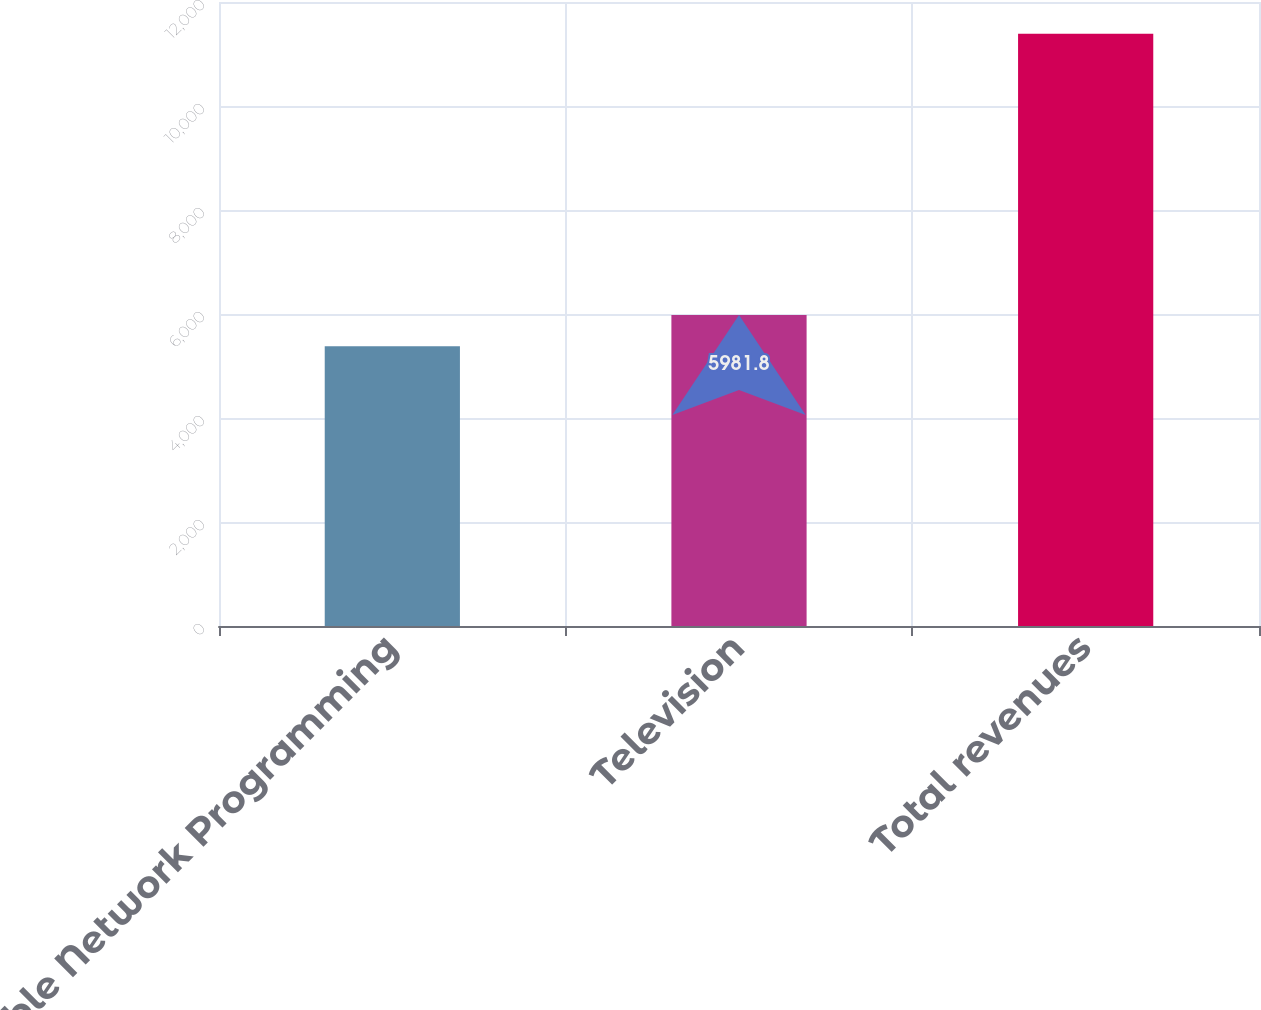Convert chart. <chart><loc_0><loc_0><loc_500><loc_500><bar_chart><fcel>Cable Network Programming<fcel>Television<fcel>Total revenues<nl><fcel>5381<fcel>5981.8<fcel>11389<nl></chart> 